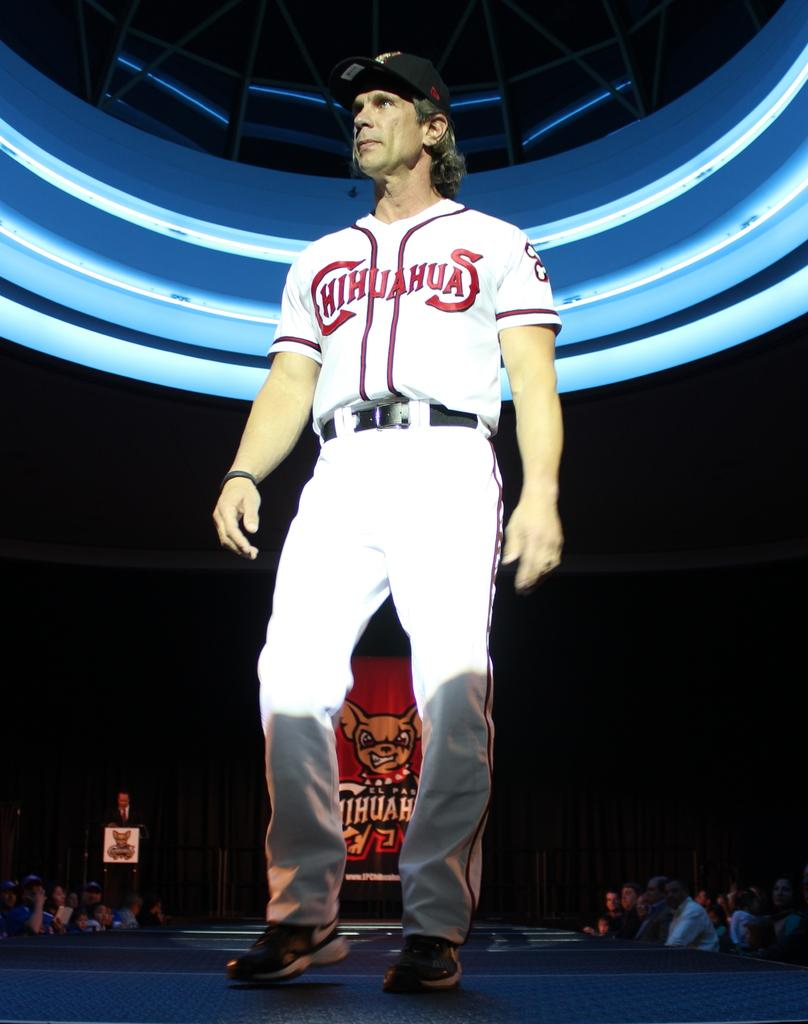<image>
Offer a succinct explanation of the picture presented. A male baseball player on a stage in his uniform for the team the Chihuahuas. 